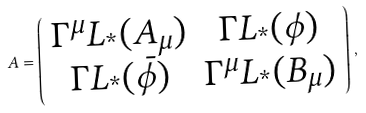Convert formula to latex. <formula><loc_0><loc_0><loc_500><loc_500>A = \left ( \begin{array} { c c } \Gamma ^ { \mu } L _ { ^ { * } } ( A _ { \mu } ) & \Gamma L _ { ^ { * } } ( \phi ) \\ \Gamma L _ { ^ { * } } ( \bar { \phi } ) & \Gamma ^ { \mu } L _ { ^ { * } } ( B _ { \mu } ) \end{array} \right ) \, ,</formula> 